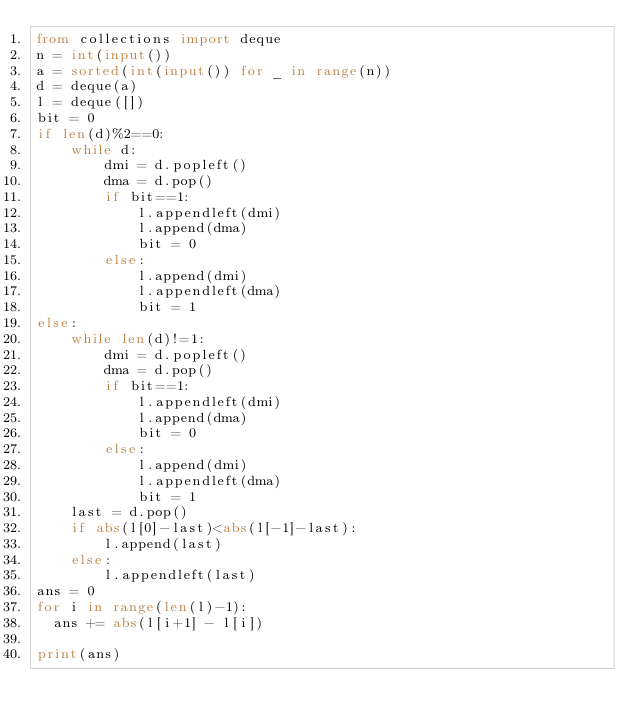Convert code to text. <code><loc_0><loc_0><loc_500><loc_500><_Python_>from collections import deque
n = int(input())
a = sorted(int(input()) for _ in range(n))
d = deque(a)
l = deque([])
bit = 0
if len(d)%2==0:
    while d:
        dmi = d.popleft()
        dma = d.pop()
        if bit==1:
            l.appendleft(dmi)
            l.append(dma)
            bit = 0
        else:
            l.append(dmi)
            l.appendleft(dma)
            bit = 1
else:
    while len(d)!=1:
        dmi = d.popleft()
        dma = d.pop()
        if bit==1:
            l.appendleft(dmi)
            l.append(dma)
            bit = 0
        else:
            l.append(dmi)
            l.appendleft(dma)
            bit = 1
    last = d.pop()
    if abs(l[0]-last)<abs(l[-1]-last):
        l.append(last)
    else:
        l.appendleft(last)
ans = 0
for i in range(len(l)-1):
  ans += abs(l[i+1] - l[i])
  
print(ans)</code> 